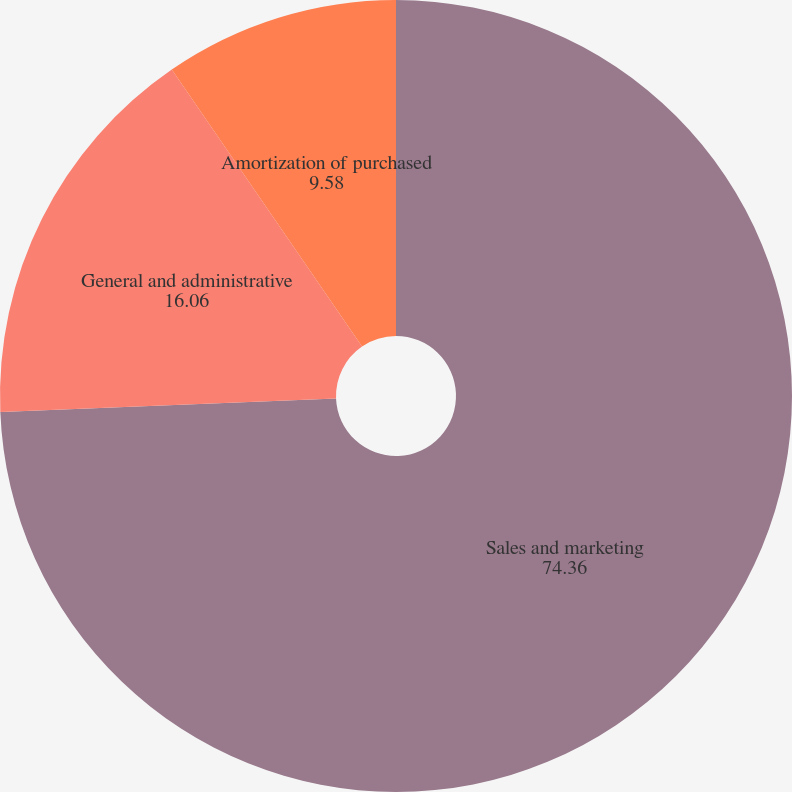Convert chart. <chart><loc_0><loc_0><loc_500><loc_500><pie_chart><fcel>Sales and marketing<fcel>General and administrative<fcel>Amortization of purchased<nl><fcel>74.36%<fcel>16.06%<fcel>9.58%<nl></chart> 